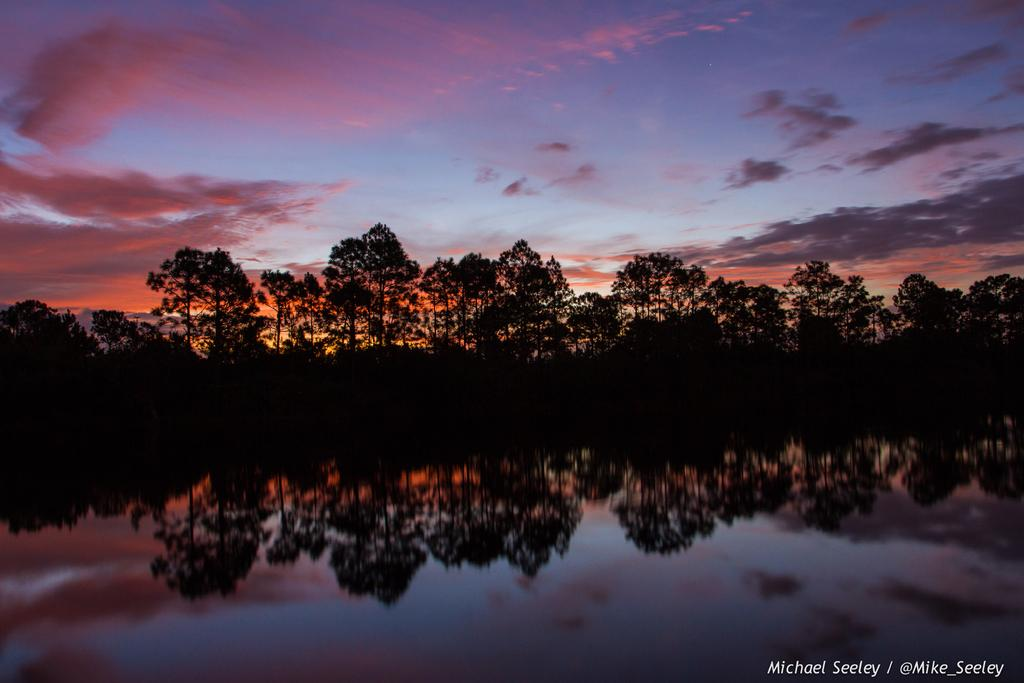What is the main subject in the foreground of the picture? There is a water body in the foreground of the picture. What is the relationship between the water body and the trees? The water body reflects the trees. What else can be seen in the middle of the picture besides the water body? There are trees in the middle of the picture. What is visible at the top of the picture? The sky is visible at the top of the picture. What type of fruit is being protested by the goat in the image? There is no fruit or goat present in the image. The image features a water body, trees, and the sky. 